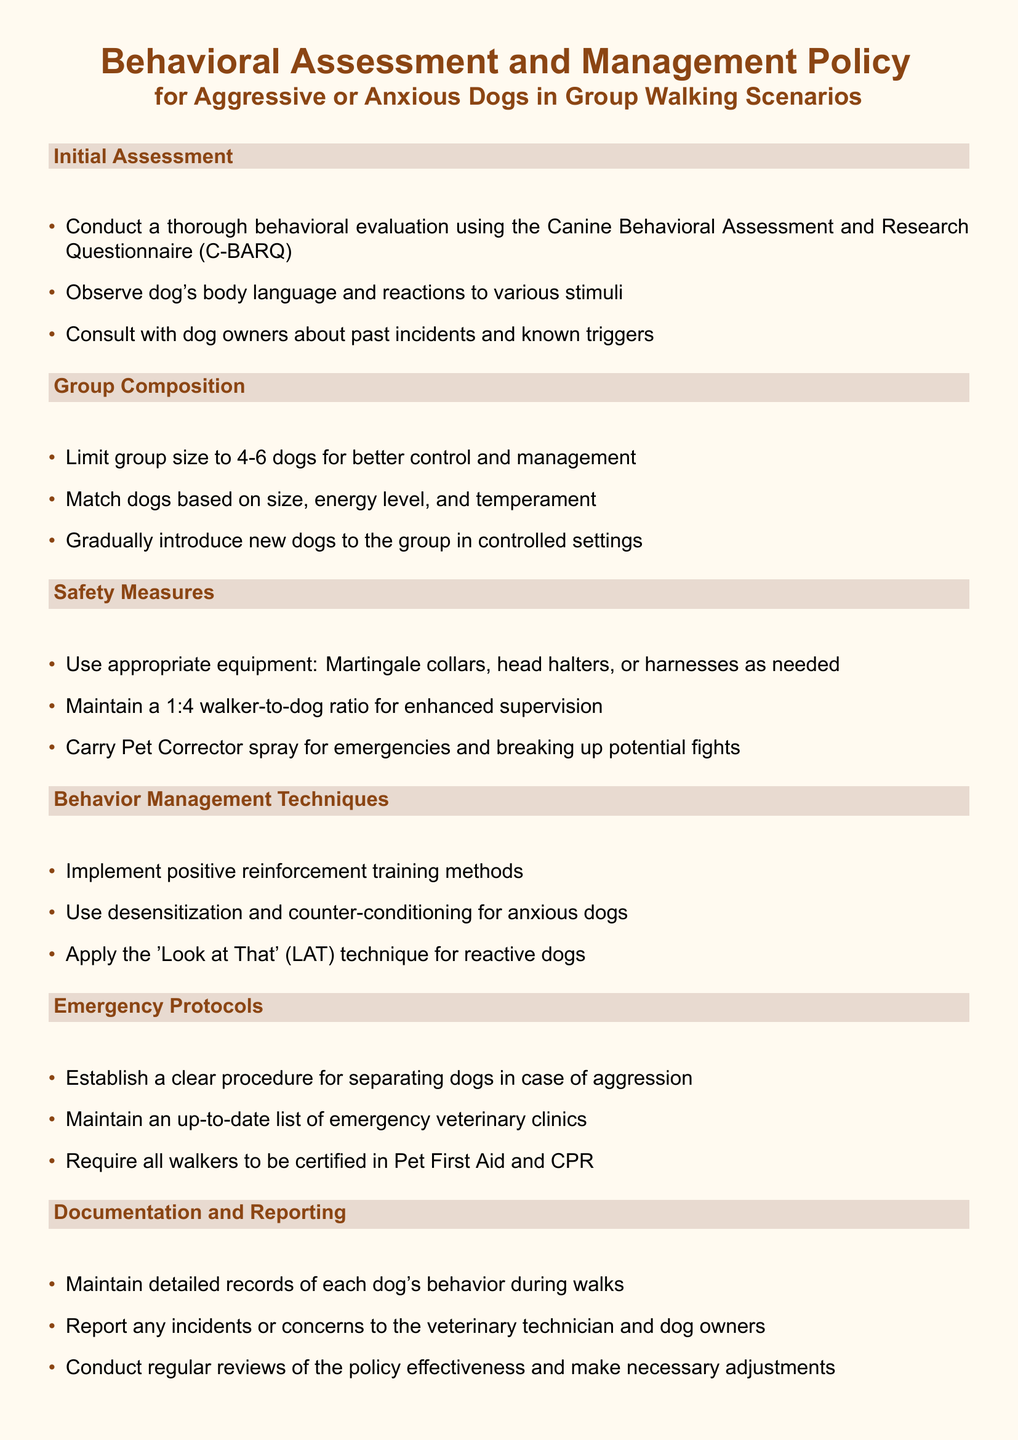What is the maximum group size for dog walking? The maximum group size ensures better control and management during walks, which is stated as 4-6 dogs.
Answer: 4-6 dogs What equipment should be used for managing aggressive dogs? The document lists appropriate equipment that includes Martingale collars, head halters, or harnesses as needed.
Answer: Martingale collars, head halters, or harnesses What behavior management technique is recommended for anxious dogs? Anxious dogs should be managed using desensitization and counter-conditioning techniques, as outlined in the document.
Answer: Desensitization and counter-conditioning What should walkers be certified in according to the emergency protocols? The requirement for certification is established for Pet First Aid and CPR to ensure safety during emergencies.
Answer: Pet First Aid and CPR How should new dogs be introduced to the group? The document suggests that new dogs should be gradually introduced to the group in controlled settings to monitor their behavior.
Answer: Gradually in controlled settings What is the dog-to-walker ratio recommended for safety? The document specifies a 1:4 walker-to-dog ratio to enhance supervision during group walks.
Answer: 1:4 What should be maintained during walks? Detailed records of each dog's behavior should be kept to track their interactions and any concerns during walks.
Answer: Detailed records of each dog's behavior Which technique is used for reactive dogs? The document mentions using the 'Look at That' technique as a specific method for managing reactive dogs.
Answer: Look at That (LAT) 